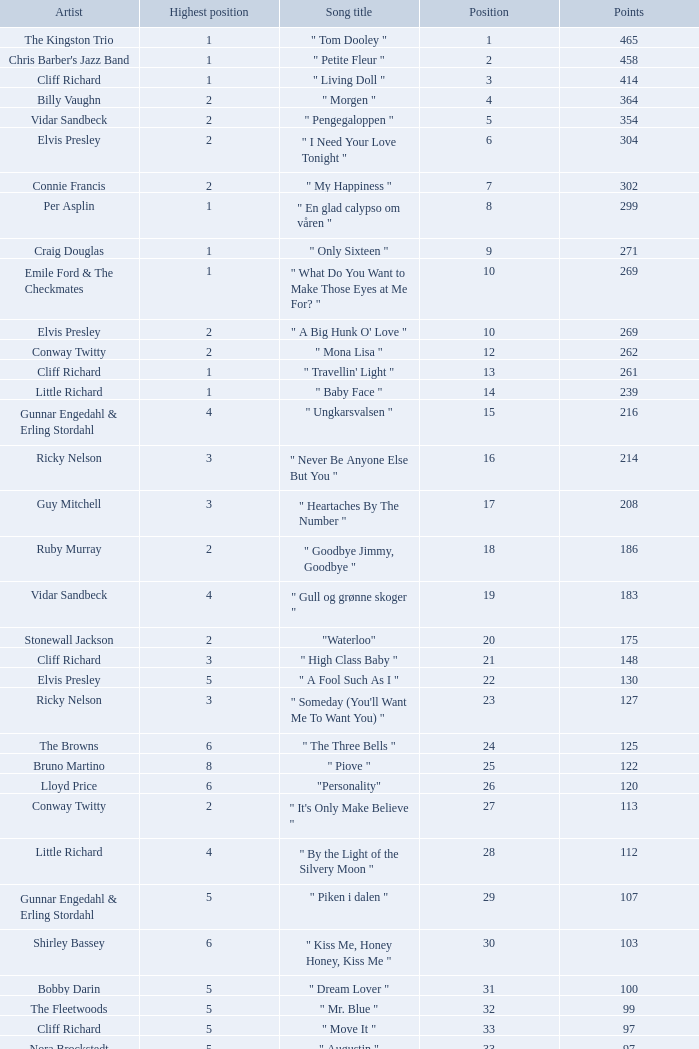What is the nme of the song performed by billy vaughn? " Morgen ". 